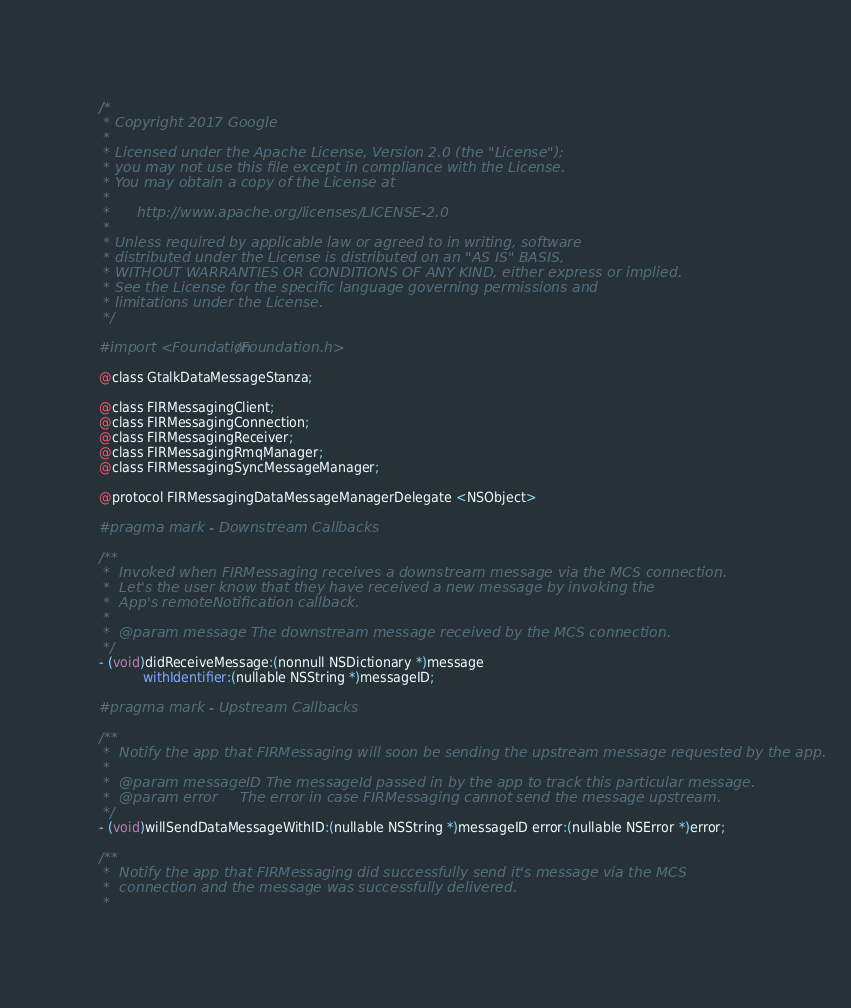Convert code to text. <code><loc_0><loc_0><loc_500><loc_500><_C_>/*
 * Copyright 2017 Google
 *
 * Licensed under the Apache License, Version 2.0 (the "License");
 * you may not use this file except in compliance with the License.
 * You may obtain a copy of the License at
 *
 *      http://www.apache.org/licenses/LICENSE-2.0
 *
 * Unless required by applicable law or agreed to in writing, software
 * distributed under the License is distributed on an "AS IS" BASIS,
 * WITHOUT WARRANTIES OR CONDITIONS OF ANY KIND, either express or implied.
 * See the License for the specific language governing permissions and
 * limitations under the License.
 */

#import <Foundation/Foundation.h>

@class GtalkDataMessageStanza;

@class FIRMessagingClient;
@class FIRMessagingConnection;
@class FIRMessagingReceiver;
@class FIRMessagingRmqManager;
@class FIRMessagingSyncMessageManager;

@protocol FIRMessagingDataMessageManagerDelegate <NSObject>

#pragma mark - Downstream Callbacks

/**
 *  Invoked when FIRMessaging receives a downstream message via the MCS connection.
 *  Let's the user know that they have received a new message by invoking the
 *  App's remoteNotification callback.
 *
 *  @param message The downstream message received by the MCS connection.
 */
- (void)didReceiveMessage:(nonnull NSDictionary *)message
           withIdentifier:(nullable NSString *)messageID;

#pragma mark - Upstream Callbacks

/**
 *  Notify the app that FIRMessaging will soon be sending the upstream message requested by the app.
 *
 *  @param messageID The messageId passed in by the app to track this particular message.
 *  @param error     The error in case FIRMessaging cannot send the message upstream.
 */
- (void)willSendDataMessageWithID:(nullable NSString *)messageID error:(nullable NSError *)error;

/**
 *  Notify the app that FIRMessaging did successfully send it's message via the MCS
 *  connection and the message was successfully delivered.
 *</code> 